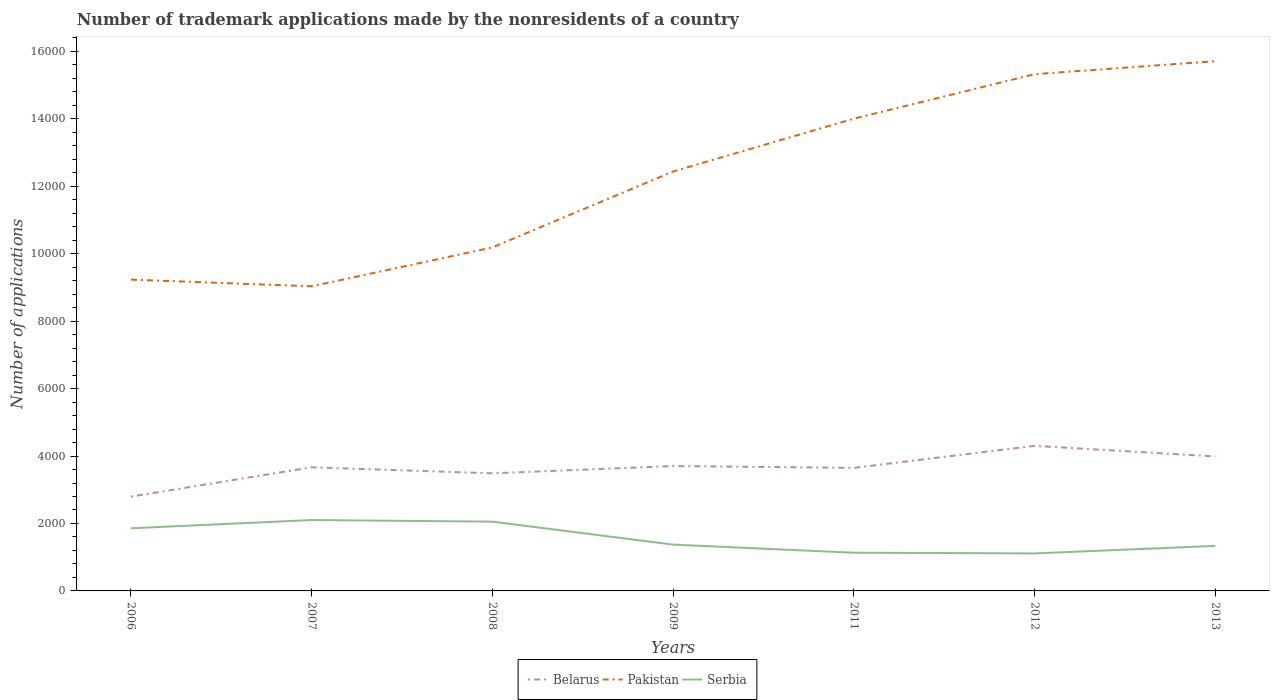How many different coloured lines are there?
Give a very brief answer. 3. Across all years, what is the maximum number of trademark applications made by the nonresidents in Serbia?
Offer a terse response. 1112. What is the total number of trademark applications made by the nonresidents in Serbia in the graph?
Provide a succinct answer. 523. What is the difference between the highest and the second highest number of trademark applications made by the nonresidents in Serbia?
Offer a very short reply. 990. What is the difference between the highest and the lowest number of trademark applications made by the nonresidents in Belarus?
Provide a succinct answer. 4. Is the number of trademark applications made by the nonresidents in Pakistan strictly greater than the number of trademark applications made by the nonresidents in Serbia over the years?
Keep it short and to the point. No. Are the values on the major ticks of Y-axis written in scientific E-notation?
Provide a succinct answer. No. How many legend labels are there?
Ensure brevity in your answer.  3. How are the legend labels stacked?
Give a very brief answer. Horizontal. What is the title of the graph?
Your answer should be compact. Number of trademark applications made by the nonresidents of a country. What is the label or title of the Y-axis?
Your response must be concise. Number of applications. What is the Number of applications of Belarus in 2006?
Your answer should be very brief. 2797. What is the Number of applications of Pakistan in 2006?
Offer a very short reply. 9231. What is the Number of applications of Serbia in 2006?
Your response must be concise. 1858. What is the Number of applications of Belarus in 2007?
Make the answer very short. 3666. What is the Number of applications in Pakistan in 2007?
Give a very brief answer. 9033. What is the Number of applications in Serbia in 2007?
Offer a very short reply. 2102. What is the Number of applications of Belarus in 2008?
Your answer should be compact. 3487. What is the Number of applications in Pakistan in 2008?
Keep it short and to the point. 1.02e+04. What is the Number of applications of Serbia in 2008?
Ensure brevity in your answer.  2054. What is the Number of applications in Belarus in 2009?
Offer a very short reply. 3703. What is the Number of applications in Pakistan in 2009?
Ensure brevity in your answer.  1.24e+04. What is the Number of applications in Serbia in 2009?
Ensure brevity in your answer.  1373. What is the Number of applications in Belarus in 2011?
Offer a terse response. 3649. What is the Number of applications of Pakistan in 2011?
Keep it short and to the point. 1.40e+04. What is the Number of applications of Serbia in 2011?
Make the answer very short. 1133. What is the Number of applications in Belarus in 2012?
Ensure brevity in your answer.  4302. What is the Number of applications of Pakistan in 2012?
Give a very brief answer. 1.53e+04. What is the Number of applications in Serbia in 2012?
Make the answer very short. 1112. What is the Number of applications of Belarus in 2013?
Make the answer very short. 3988. What is the Number of applications in Pakistan in 2013?
Make the answer very short. 1.57e+04. What is the Number of applications in Serbia in 2013?
Provide a short and direct response. 1335. Across all years, what is the maximum Number of applications of Belarus?
Keep it short and to the point. 4302. Across all years, what is the maximum Number of applications in Pakistan?
Provide a short and direct response. 1.57e+04. Across all years, what is the maximum Number of applications in Serbia?
Your answer should be compact. 2102. Across all years, what is the minimum Number of applications in Belarus?
Ensure brevity in your answer.  2797. Across all years, what is the minimum Number of applications in Pakistan?
Your answer should be compact. 9033. Across all years, what is the minimum Number of applications in Serbia?
Provide a short and direct response. 1112. What is the total Number of applications of Belarus in the graph?
Provide a succinct answer. 2.56e+04. What is the total Number of applications in Pakistan in the graph?
Offer a terse response. 8.59e+04. What is the total Number of applications in Serbia in the graph?
Your answer should be very brief. 1.10e+04. What is the difference between the Number of applications of Belarus in 2006 and that in 2007?
Provide a short and direct response. -869. What is the difference between the Number of applications in Pakistan in 2006 and that in 2007?
Your response must be concise. 198. What is the difference between the Number of applications of Serbia in 2006 and that in 2007?
Provide a short and direct response. -244. What is the difference between the Number of applications in Belarus in 2006 and that in 2008?
Your response must be concise. -690. What is the difference between the Number of applications in Pakistan in 2006 and that in 2008?
Your answer should be compact. -955. What is the difference between the Number of applications of Serbia in 2006 and that in 2008?
Provide a short and direct response. -196. What is the difference between the Number of applications in Belarus in 2006 and that in 2009?
Your response must be concise. -906. What is the difference between the Number of applications in Pakistan in 2006 and that in 2009?
Your response must be concise. -3206. What is the difference between the Number of applications of Serbia in 2006 and that in 2009?
Make the answer very short. 485. What is the difference between the Number of applications of Belarus in 2006 and that in 2011?
Offer a very short reply. -852. What is the difference between the Number of applications in Pakistan in 2006 and that in 2011?
Offer a terse response. -4772. What is the difference between the Number of applications in Serbia in 2006 and that in 2011?
Make the answer very short. 725. What is the difference between the Number of applications in Belarus in 2006 and that in 2012?
Keep it short and to the point. -1505. What is the difference between the Number of applications in Pakistan in 2006 and that in 2012?
Offer a very short reply. -6092. What is the difference between the Number of applications of Serbia in 2006 and that in 2012?
Ensure brevity in your answer.  746. What is the difference between the Number of applications of Belarus in 2006 and that in 2013?
Offer a very short reply. -1191. What is the difference between the Number of applications in Pakistan in 2006 and that in 2013?
Provide a short and direct response. -6477. What is the difference between the Number of applications of Serbia in 2006 and that in 2013?
Give a very brief answer. 523. What is the difference between the Number of applications in Belarus in 2007 and that in 2008?
Offer a very short reply. 179. What is the difference between the Number of applications of Pakistan in 2007 and that in 2008?
Provide a succinct answer. -1153. What is the difference between the Number of applications of Serbia in 2007 and that in 2008?
Give a very brief answer. 48. What is the difference between the Number of applications of Belarus in 2007 and that in 2009?
Provide a short and direct response. -37. What is the difference between the Number of applications in Pakistan in 2007 and that in 2009?
Your answer should be very brief. -3404. What is the difference between the Number of applications in Serbia in 2007 and that in 2009?
Make the answer very short. 729. What is the difference between the Number of applications of Pakistan in 2007 and that in 2011?
Your answer should be compact. -4970. What is the difference between the Number of applications of Serbia in 2007 and that in 2011?
Provide a succinct answer. 969. What is the difference between the Number of applications in Belarus in 2007 and that in 2012?
Your answer should be compact. -636. What is the difference between the Number of applications of Pakistan in 2007 and that in 2012?
Give a very brief answer. -6290. What is the difference between the Number of applications of Serbia in 2007 and that in 2012?
Offer a very short reply. 990. What is the difference between the Number of applications of Belarus in 2007 and that in 2013?
Make the answer very short. -322. What is the difference between the Number of applications of Pakistan in 2007 and that in 2013?
Your response must be concise. -6675. What is the difference between the Number of applications of Serbia in 2007 and that in 2013?
Ensure brevity in your answer.  767. What is the difference between the Number of applications of Belarus in 2008 and that in 2009?
Provide a short and direct response. -216. What is the difference between the Number of applications of Pakistan in 2008 and that in 2009?
Your response must be concise. -2251. What is the difference between the Number of applications of Serbia in 2008 and that in 2009?
Keep it short and to the point. 681. What is the difference between the Number of applications in Belarus in 2008 and that in 2011?
Your answer should be very brief. -162. What is the difference between the Number of applications in Pakistan in 2008 and that in 2011?
Your response must be concise. -3817. What is the difference between the Number of applications of Serbia in 2008 and that in 2011?
Offer a very short reply. 921. What is the difference between the Number of applications in Belarus in 2008 and that in 2012?
Make the answer very short. -815. What is the difference between the Number of applications in Pakistan in 2008 and that in 2012?
Your answer should be compact. -5137. What is the difference between the Number of applications in Serbia in 2008 and that in 2012?
Your answer should be very brief. 942. What is the difference between the Number of applications of Belarus in 2008 and that in 2013?
Offer a terse response. -501. What is the difference between the Number of applications in Pakistan in 2008 and that in 2013?
Offer a terse response. -5522. What is the difference between the Number of applications of Serbia in 2008 and that in 2013?
Your response must be concise. 719. What is the difference between the Number of applications of Belarus in 2009 and that in 2011?
Offer a very short reply. 54. What is the difference between the Number of applications in Pakistan in 2009 and that in 2011?
Provide a succinct answer. -1566. What is the difference between the Number of applications in Serbia in 2009 and that in 2011?
Your response must be concise. 240. What is the difference between the Number of applications in Belarus in 2009 and that in 2012?
Ensure brevity in your answer.  -599. What is the difference between the Number of applications in Pakistan in 2009 and that in 2012?
Offer a very short reply. -2886. What is the difference between the Number of applications in Serbia in 2009 and that in 2012?
Your response must be concise. 261. What is the difference between the Number of applications of Belarus in 2009 and that in 2013?
Give a very brief answer. -285. What is the difference between the Number of applications in Pakistan in 2009 and that in 2013?
Your response must be concise. -3271. What is the difference between the Number of applications of Belarus in 2011 and that in 2012?
Your answer should be compact. -653. What is the difference between the Number of applications of Pakistan in 2011 and that in 2012?
Provide a succinct answer. -1320. What is the difference between the Number of applications in Belarus in 2011 and that in 2013?
Your response must be concise. -339. What is the difference between the Number of applications in Pakistan in 2011 and that in 2013?
Make the answer very short. -1705. What is the difference between the Number of applications of Serbia in 2011 and that in 2013?
Make the answer very short. -202. What is the difference between the Number of applications of Belarus in 2012 and that in 2013?
Make the answer very short. 314. What is the difference between the Number of applications of Pakistan in 2012 and that in 2013?
Keep it short and to the point. -385. What is the difference between the Number of applications of Serbia in 2012 and that in 2013?
Give a very brief answer. -223. What is the difference between the Number of applications in Belarus in 2006 and the Number of applications in Pakistan in 2007?
Make the answer very short. -6236. What is the difference between the Number of applications of Belarus in 2006 and the Number of applications of Serbia in 2007?
Your answer should be very brief. 695. What is the difference between the Number of applications in Pakistan in 2006 and the Number of applications in Serbia in 2007?
Offer a terse response. 7129. What is the difference between the Number of applications of Belarus in 2006 and the Number of applications of Pakistan in 2008?
Make the answer very short. -7389. What is the difference between the Number of applications of Belarus in 2006 and the Number of applications of Serbia in 2008?
Keep it short and to the point. 743. What is the difference between the Number of applications of Pakistan in 2006 and the Number of applications of Serbia in 2008?
Offer a terse response. 7177. What is the difference between the Number of applications in Belarus in 2006 and the Number of applications in Pakistan in 2009?
Provide a short and direct response. -9640. What is the difference between the Number of applications of Belarus in 2006 and the Number of applications of Serbia in 2009?
Provide a succinct answer. 1424. What is the difference between the Number of applications in Pakistan in 2006 and the Number of applications in Serbia in 2009?
Offer a terse response. 7858. What is the difference between the Number of applications in Belarus in 2006 and the Number of applications in Pakistan in 2011?
Make the answer very short. -1.12e+04. What is the difference between the Number of applications in Belarus in 2006 and the Number of applications in Serbia in 2011?
Give a very brief answer. 1664. What is the difference between the Number of applications of Pakistan in 2006 and the Number of applications of Serbia in 2011?
Offer a terse response. 8098. What is the difference between the Number of applications in Belarus in 2006 and the Number of applications in Pakistan in 2012?
Offer a very short reply. -1.25e+04. What is the difference between the Number of applications of Belarus in 2006 and the Number of applications of Serbia in 2012?
Ensure brevity in your answer.  1685. What is the difference between the Number of applications in Pakistan in 2006 and the Number of applications in Serbia in 2012?
Keep it short and to the point. 8119. What is the difference between the Number of applications of Belarus in 2006 and the Number of applications of Pakistan in 2013?
Make the answer very short. -1.29e+04. What is the difference between the Number of applications of Belarus in 2006 and the Number of applications of Serbia in 2013?
Your response must be concise. 1462. What is the difference between the Number of applications of Pakistan in 2006 and the Number of applications of Serbia in 2013?
Offer a terse response. 7896. What is the difference between the Number of applications in Belarus in 2007 and the Number of applications in Pakistan in 2008?
Make the answer very short. -6520. What is the difference between the Number of applications in Belarus in 2007 and the Number of applications in Serbia in 2008?
Offer a very short reply. 1612. What is the difference between the Number of applications in Pakistan in 2007 and the Number of applications in Serbia in 2008?
Your answer should be very brief. 6979. What is the difference between the Number of applications of Belarus in 2007 and the Number of applications of Pakistan in 2009?
Your response must be concise. -8771. What is the difference between the Number of applications of Belarus in 2007 and the Number of applications of Serbia in 2009?
Ensure brevity in your answer.  2293. What is the difference between the Number of applications in Pakistan in 2007 and the Number of applications in Serbia in 2009?
Offer a terse response. 7660. What is the difference between the Number of applications of Belarus in 2007 and the Number of applications of Pakistan in 2011?
Keep it short and to the point. -1.03e+04. What is the difference between the Number of applications in Belarus in 2007 and the Number of applications in Serbia in 2011?
Keep it short and to the point. 2533. What is the difference between the Number of applications in Pakistan in 2007 and the Number of applications in Serbia in 2011?
Keep it short and to the point. 7900. What is the difference between the Number of applications in Belarus in 2007 and the Number of applications in Pakistan in 2012?
Keep it short and to the point. -1.17e+04. What is the difference between the Number of applications of Belarus in 2007 and the Number of applications of Serbia in 2012?
Offer a terse response. 2554. What is the difference between the Number of applications in Pakistan in 2007 and the Number of applications in Serbia in 2012?
Your response must be concise. 7921. What is the difference between the Number of applications of Belarus in 2007 and the Number of applications of Pakistan in 2013?
Your answer should be compact. -1.20e+04. What is the difference between the Number of applications in Belarus in 2007 and the Number of applications in Serbia in 2013?
Your response must be concise. 2331. What is the difference between the Number of applications in Pakistan in 2007 and the Number of applications in Serbia in 2013?
Make the answer very short. 7698. What is the difference between the Number of applications of Belarus in 2008 and the Number of applications of Pakistan in 2009?
Provide a succinct answer. -8950. What is the difference between the Number of applications in Belarus in 2008 and the Number of applications in Serbia in 2009?
Give a very brief answer. 2114. What is the difference between the Number of applications in Pakistan in 2008 and the Number of applications in Serbia in 2009?
Give a very brief answer. 8813. What is the difference between the Number of applications of Belarus in 2008 and the Number of applications of Pakistan in 2011?
Make the answer very short. -1.05e+04. What is the difference between the Number of applications of Belarus in 2008 and the Number of applications of Serbia in 2011?
Your response must be concise. 2354. What is the difference between the Number of applications of Pakistan in 2008 and the Number of applications of Serbia in 2011?
Provide a short and direct response. 9053. What is the difference between the Number of applications of Belarus in 2008 and the Number of applications of Pakistan in 2012?
Give a very brief answer. -1.18e+04. What is the difference between the Number of applications in Belarus in 2008 and the Number of applications in Serbia in 2012?
Offer a very short reply. 2375. What is the difference between the Number of applications in Pakistan in 2008 and the Number of applications in Serbia in 2012?
Your answer should be very brief. 9074. What is the difference between the Number of applications of Belarus in 2008 and the Number of applications of Pakistan in 2013?
Provide a succinct answer. -1.22e+04. What is the difference between the Number of applications in Belarus in 2008 and the Number of applications in Serbia in 2013?
Offer a terse response. 2152. What is the difference between the Number of applications in Pakistan in 2008 and the Number of applications in Serbia in 2013?
Provide a succinct answer. 8851. What is the difference between the Number of applications in Belarus in 2009 and the Number of applications in Pakistan in 2011?
Your answer should be very brief. -1.03e+04. What is the difference between the Number of applications of Belarus in 2009 and the Number of applications of Serbia in 2011?
Offer a very short reply. 2570. What is the difference between the Number of applications in Pakistan in 2009 and the Number of applications in Serbia in 2011?
Make the answer very short. 1.13e+04. What is the difference between the Number of applications in Belarus in 2009 and the Number of applications in Pakistan in 2012?
Offer a terse response. -1.16e+04. What is the difference between the Number of applications of Belarus in 2009 and the Number of applications of Serbia in 2012?
Your answer should be compact. 2591. What is the difference between the Number of applications in Pakistan in 2009 and the Number of applications in Serbia in 2012?
Provide a short and direct response. 1.13e+04. What is the difference between the Number of applications of Belarus in 2009 and the Number of applications of Pakistan in 2013?
Provide a short and direct response. -1.20e+04. What is the difference between the Number of applications of Belarus in 2009 and the Number of applications of Serbia in 2013?
Your answer should be compact. 2368. What is the difference between the Number of applications of Pakistan in 2009 and the Number of applications of Serbia in 2013?
Offer a very short reply. 1.11e+04. What is the difference between the Number of applications of Belarus in 2011 and the Number of applications of Pakistan in 2012?
Your answer should be very brief. -1.17e+04. What is the difference between the Number of applications of Belarus in 2011 and the Number of applications of Serbia in 2012?
Your answer should be very brief. 2537. What is the difference between the Number of applications in Pakistan in 2011 and the Number of applications in Serbia in 2012?
Ensure brevity in your answer.  1.29e+04. What is the difference between the Number of applications of Belarus in 2011 and the Number of applications of Pakistan in 2013?
Keep it short and to the point. -1.21e+04. What is the difference between the Number of applications in Belarus in 2011 and the Number of applications in Serbia in 2013?
Give a very brief answer. 2314. What is the difference between the Number of applications of Pakistan in 2011 and the Number of applications of Serbia in 2013?
Give a very brief answer. 1.27e+04. What is the difference between the Number of applications of Belarus in 2012 and the Number of applications of Pakistan in 2013?
Ensure brevity in your answer.  -1.14e+04. What is the difference between the Number of applications in Belarus in 2012 and the Number of applications in Serbia in 2013?
Ensure brevity in your answer.  2967. What is the difference between the Number of applications in Pakistan in 2012 and the Number of applications in Serbia in 2013?
Make the answer very short. 1.40e+04. What is the average Number of applications of Belarus per year?
Give a very brief answer. 3656. What is the average Number of applications in Pakistan per year?
Offer a terse response. 1.23e+04. What is the average Number of applications in Serbia per year?
Give a very brief answer. 1566.71. In the year 2006, what is the difference between the Number of applications in Belarus and Number of applications in Pakistan?
Give a very brief answer. -6434. In the year 2006, what is the difference between the Number of applications of Belarus and Number of applications of Serbia?
Your answer should be compact. 939. In the year 2006, what is the difference between the Number of applications of Pakistan and Number of applications of Serbia?
Keep it short and to the point. 7373. In the year 2007, what is the difference between the Number of applications in Belarus and Number of applications in Pakistan?
Make the answer very short. -5367. In the year 2007, what is the difference between the Number of applications of Belarus and Number of applications of Serbia?
Make the answer very short. 1564. In the year 2007, what is the difference between the Number of applications of Pakistan and Number of applications of Serbia?
Your answer should be compact. 6931. In the year 2008, what is the difference between the Number of applications of Belarus and Number of applications of Pakistan?
Provide a succinct answer. -6699. In the year 2008, what is the difference between the Number of applications of Belarus and Number of applications of Serbia?
Give a very brief answer. 1433. In the year 2008, what is the difference between the Number of applications in Pakistan and Number of applications in Serbia?
Ensure brevity in your answer.  8132. In the year 2009, what is the difference between the Number of applications in Belarus and Number of applications in Pakistan?
Your response must be concise. -8734. In the year 2009, what is the difference between the Number of applications in Belarus and Number of applications in Serbia?
Make the answer very short. 2330. In the year 2009, what is the difference between the Number of applications in Pakistan and Number of applications in Serbia?
Offer a very short reply. 1.11e+04. In the year 2011, what is the difference between the Number of applications of Belarus and Number of applications of Pakistan?
Provide a short and direct response. -1.04e+04. In the year 2011, what is the difference between the Number of applications of Belarus and Number of applications of Serbia?
Your answer should be very brief. 2516. In the year 2011, what is the difference between the Number of applications of Pakistan and Number of applications of Serbia?
Ensure brevity in your answer.  1.29e+04. In the year 2012, what is the difference between the Number of applications of Belarus and Number of applications of Pakistan?
Keep it short and to the point. -1.10e+04. In the year 2012, what is the difference between the Number of applications in Belarus and Number of applications in Serbia?
Provide a succinct answer. 3190. In the year 2012, what is the difference between the Number of applications of Pakistan and Number of applications of Serbia?
Offer a very short reply. 1.42e+04. In the year 2013, what is the difference between the Number of applications of Belarus and Number of applications of Pakistan?
Your answer should be very brief. -1.17e+04. In the year 2013, what is the difference between the Number of applications of Belarus and Number of applications of Serbia?
Your answer should be compact. 2653. In the year 2013, what is the difference between the Number of applications in Pakistan and Number of applications in Serbia?
Make the answer very short. 1.44e+04. What is the ratio of the Number of applications of Belarus in 2006 to that in 2007?
Provide a short and direct response. 0.76. What is the ratio of the Number of applications in Pakistan in 2006 to that in 2007?
Give a very brief answer. 1.02. What is the ratio of the Number of applications of Serbia in 2006 to that in 2007?
Provide a short and direct response. 0.88. What is the ratio of the Number of applications in Belarus in 2006 to that in 2008?
Your answer should be very brief. 0.8. What is the ratio of the Number of applications in Pakistan in 2006 to that in 2008?
Ensure brevity in your answer.  0.91. What is the ratio of the Number of applications of Serbia in 2006 to that in 2008?
Offer a very short reply. 0.9. What is the ratio of the Number of applications of Belarus in 2006 to that in 2009?
Give a very brief answer. 0.76. What is the ratio of the Number of applications of Pakistan in 2006 to that in 2009?
Keep it short and to the point. 0.74. What is the ratio of the Number of applications of Serbia in 2006 to that in 2009?
Give a very brief answer. 1.35. What is the ratio of the Number of applications of Belarus in 2006 to that in 2011?
Make the answer very short. 0.77. What is the ratio of the Number of applications in Pakistan in 2006 to that in 2011?
Offer a very short reply. 0.66. What is the ratio of the Number of applications in Serbia in 2006 to that in 2011?
Offer a terse response. 1.64. What is the ratio of the Number of applications in Belarus in 2006 to that in 2012?
Your answer should be compact. 0.65. What is the ratio of the Number of applications in Pakistan in 2006 to that in 2012?
Give a very brief answer. 0.6. What is the ratio of the Number of applications in Serbia in 2006 to that in 2012?
Ensure brevity in your answer.  1.67. What is the ratio of the Number of applications of Belarus in 2006 to that in 2013?
Provide a succinct answer. 0.7. What is the ratio of the Number of applications in Pakistan in 2006 to that in 2013?
Provide a succinct answer. 0.59. What is the ratio of the Number of applications in Serbia in 2006 to that in 2013?
Provide a short and direct response. 1.39. What is the ratio of the Number of applications of Belarus in 2007 to that in 2008?
Offer a terse response. 1.05. What is the ratio of the Number of applications in Pakistan in 2007 to that in 2008?
Offer a terse response. 0.89. What is the ratio of the Number of applications in Serbia in 2007 to that in 2008?
Offer a terse response. 1.02. What is the ratio of the Number of applications in Belarus in 2007 to that in 2009?
Keep it short and to the point. 0.99. What is the ratio of the Number of applications of Pakistan in 2007 to that in 2009?
Give a very brief answer. 0.73. What is the ratio of the Number of applications of Serbia in 2007 to that in 2009?
Offer a terse response. 1.53. What is the ratio of the Number of applications in Belarus in 2007 to that in 2011?
Give a very brief answer. 1. What is the ratio of the Number of applications in Pakistan in 2007 to that in 2011?
Offer a terse response. 0.65. What is the ratio of the Number of applications of Serbia in 2007 to that in 2011?
Offer a terse response. 1.86. What is the ratio of the Number of applications of Belarus in 2007 to that in 2012?
Give a very brief answer. 0.85. What is the ratio of the Number of applications of Pakistan in 2007 to that in 2012?
Keep it short and to the point. 0.59. What is the ratio of the Number of applications of Serbia in 2007 to that in 2012?
Your answer should be very brief. 1.89. What is the ratio of the Number of applications in Belarus in 2007 to that in 2013?
Your answer should be very brief. 0.92. What is the ratio of the Number of applications in Pakistan in 2007 to that in 2013?
Offer a very short reply. 0.58. What is the ratio of the Number of applications of Serbia in 2007 to that in 2013?
Make the answer very short. 1.57. What is the ratio of the Number of applications of Belarus in 2008 to that in 2009?
Ensure brevity in your answer.  0.94. What is the ratio of the Number of applications in Pakistan in 2008 to that in 2009?
Provide a short and direct response. 0.82. What is the ratio of the Number of applications of Serbia in 2008 to that in 2009?
Make the answer very short. 1.5. What is the ratio of the Number of applications in Belarus in 2008 to that in 2011?
Provide a succinct answer. 0.96. What is the ratio of the Number of applications in Pakistan in 2008 to that in 2011?
Ensure brevity in your answer.  0.73. What is the ratio of the Number of applications in Serbia in 2008 to that in 2011?
Provide a succinct answer. 1.81. What is the ratio of the Number of applications of Belarus in 2008 to that in 2012?
Offer a terse response. 0.81. What is the ratio of the Number of applications of Pakistan in 2008 to that in 2012?
Provide a short and direct response. 0.66. What is the ratio of the Number of applications of Serbia in 2008 to that in 2012?
Ensure brevity in your answer.  1.85. What is the ratio of the Number of applications in Belarus in 2008 to that in 2013?
Keep it short and to the point. 0.87. What is the ratio of the Number of applications of Pakistan in 2008 to that in 2013?
Offer a terse response. 0.65. What is the ratio of the Number of applications in Serbia in 2008 to that in 2013?
Provide a succinct answer. 1.54. What is the ratio of the Number of applications of Belarus in 2009 to that in 2011?
Give a very brief answer. 1.01. What is the ratio of the Number of applications in Pakistan in 2009 to that in 2011?
Offer a terse response. 0.89. What is the ratio of the Number of applications in Serbia in 2009 to that in 2011?
Your answer should be compact. 1.21. What is the ratio of the Number of applications of Belarus in 2009 to that in 2012?
Offer a terse response. 0.86. What is the ratio of the Number of applications in Pakistan in 2009 to that in 2012?
Your answer should be compact. 0.81. What is the ratio of the Number of applications in Serbia in 2009 to that in 2012?
Your answer should be compact. 1.23. What is the ratio of the Number of applications in Belarus in 2009 to that in 2013?
Your response must be concise. 0.93. What is the ratio of the Number of applications in Pakistan in 2009 to that in 2013?
Your answer should be very brief. 0.79. What is the ratio of the Number of applications in Serbia in 2009 to that in 2013?
Keep it short and to the point. 1.03. What is the ratio of the Number of applications of Belarus in 2011 to that in 2012?
Provide a succinct answer. 0.85. What is the ratio of the Number of applications in Pakistan in 2011 to that in 2012?
Your response must be concise. 0.91. What is the ratio of the Number of applications in Serbia in 2011 to that in 2012?
Make the answer very short. 1.02. What is the ratio of the Number of applications in Belarus in 2011 to that in 2013?
Your answer should be very brief. 0.92. What is the ratio of the Number of applications in Pakistan in 2011 to that in 2013?
Your response must be concise. 0.89. What is the ratio of the Number of applications of Serbia in 2011 to that in 2013?
Offer a very short reply. 0.85. What is the ratio of the Number of applications in Belarus in 2012 to that in 2013?
Your answer should be very brief. 1.08. What is the ratio of the Number of applications in Pakistan in 2012 to that in 2013?
Offer a very short reply. 0.98. What is the ratio of the Number of applications in Serbia in 2012 to that in 2013?
Provide a succinct answer. 0.83. What is the difference between the highest and the second highest Number of applications in Belarus?
Offer a terse response. 314. What is the difference between the highest and the second highest Number of applications in Pakistan?
Make the answer very short. 385. What is the difference between the highest and the second highest Number of applications of Serbia?
Ensure brevity in your answer.  48. What is the difference between the highest and the lowest Number of applications in Belarus?
Ensure brevity in your answer.  1505. What is the difference between the highest and the lowest Number of applications of Pakistan?
Keep it short and to the point. 6675. What is the difference between the highest and the lowest Number of applications of Serbia?
Your response must be concise. 990. 